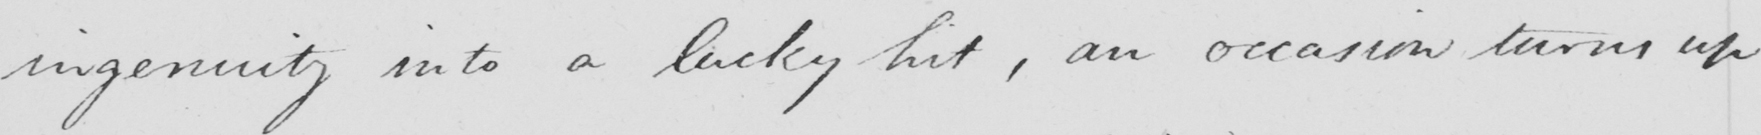What text is written in this handwritten line? ingenuity into a lucky hit , an occasion turns up 